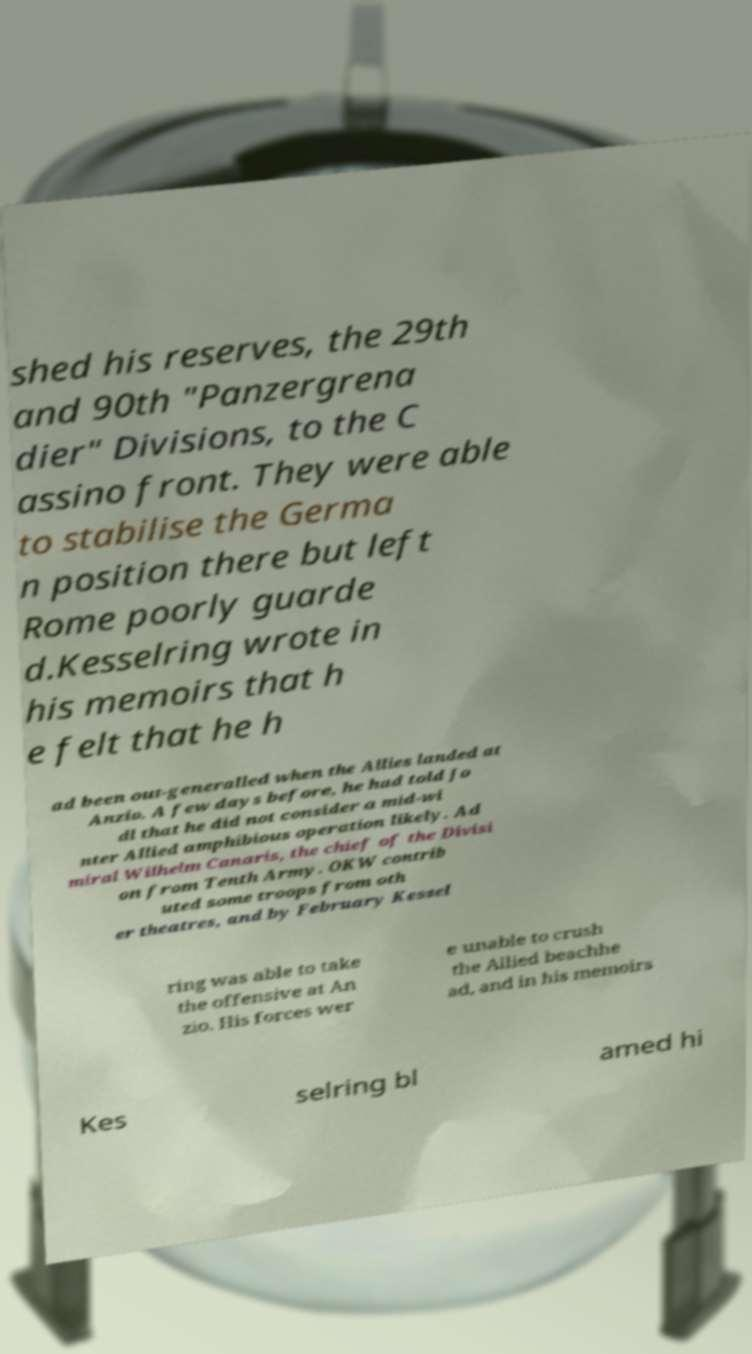I need the written content from this picture converted into text. Can you do that? shed his reserves, the 29th and 90th "Panzergrena dier" Divisions, to the C assino front. They were able to stabilise the Germa n position there but left Rome poorly guarde d.Kesselring wrote in his memoirs that h e felt that he h ad been out-generalled when the Allies landed at Anzio. A few days before, he had told Jo dl that he did not consider a mid-wi nter Allied amphibious operation likely. Ad miral Wilhelm Canaris, the chief of the Divisi on from Tenth Army. OKW contrib uted some troops from oth er theatres, and by February Kessel ring was able to take the offensive at An zio. His forces wer e unable to crush the Allied beachhe ad, and in his memoirs Kes selring bl amed hi 